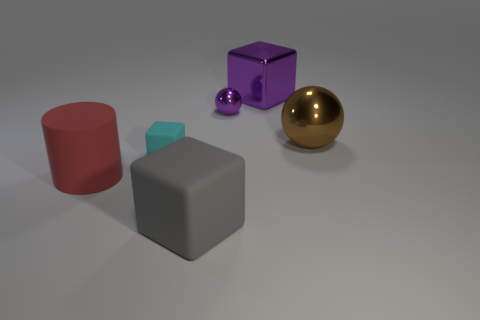Add 2 cylinders. How many objects exist? 8 Subtract all spheres. How many objects are left? 4 Add 5 large gray matte blocks. How many large gray matte blocks are left? 6 Add 2 small rubber things. How many small rubber things exist? 3 Subtract 0 cyan cylinders. How many objects are left? 6 Subtract all rubber objects. Subtract all purple spheres. How many objects are left? 2 